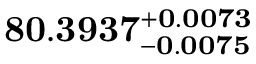Convert formula to latex. <formula><loc_0><loc_0><loc_500><loc_500>8 0 . 3 9 3 7 _ { - 0 . 0 0 7 5 } ^ { + 0 . 0 0 7 3 }</formula> 